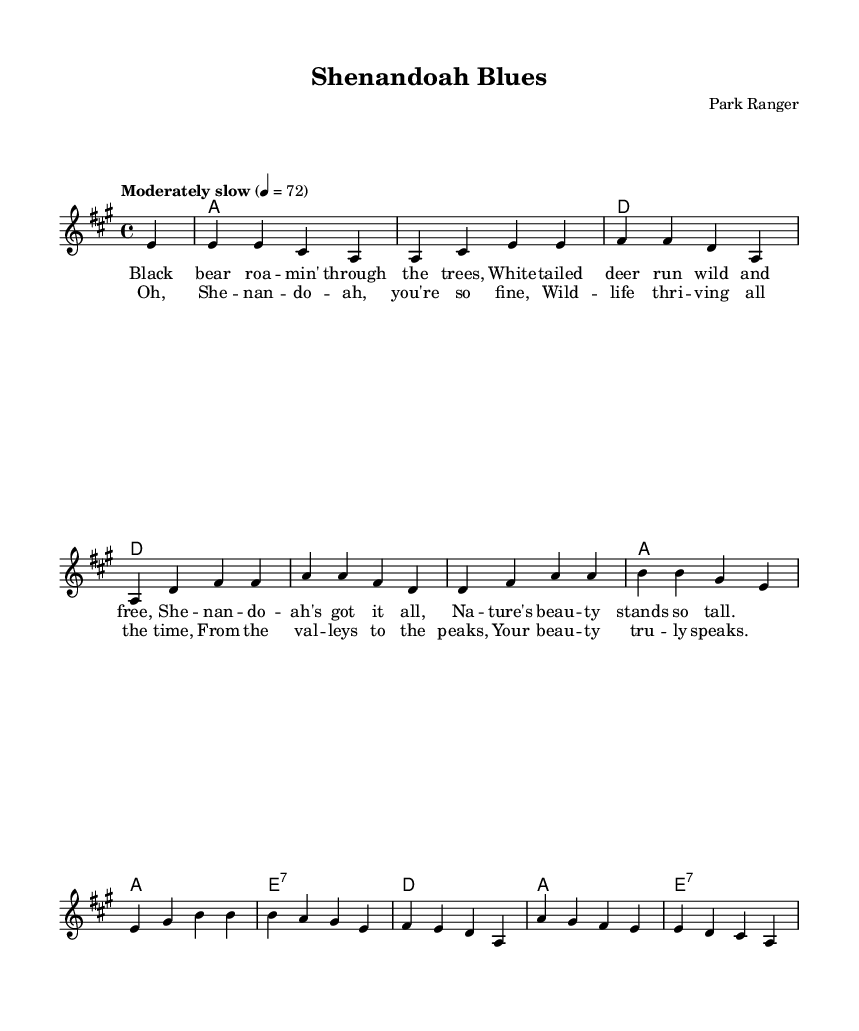What is the key signature of this music? The key signature is A major, which has three sharps (F#, C#, and G#).
Answer: A major What is the time signature of the piece? The time signature is indicated at the beginning of the score as 4/4, meaning there are four beats in each measure and a quarter note receives one beat.
Answer: 4/4 What is the tempo marking for this piece? The tempo is marked as "Moderately slow" with a tempo of 72 beats per minute, indicating a relaxed pace.
Answer: Moderately slow How many verses does this piece have? The piece has one verse as indicated by the lyrics associated with the melody before the chorus, which is typical for many blues songs.
Answer: One What is the first lyric line of the verse? The first line of the verse starts with "Black bear roa -- min' through the trees," representing the celebration of wildlife in Shenandoah National Park.
Answer: Black bear roa -- min' through the trees How often does the chord A appear in the harmonies? The chord A appears four times in the harmonies, as seen in the chord progression in the score, emphasizing its significance in the song structure.
Answer: Four What is the theme of the song? The theme revolves around celebrating the diverse wildlife found in Shenandoah National Park, as illustrated by the lyrics focusing on animals and nature.
Answer: Wildlife celebration 